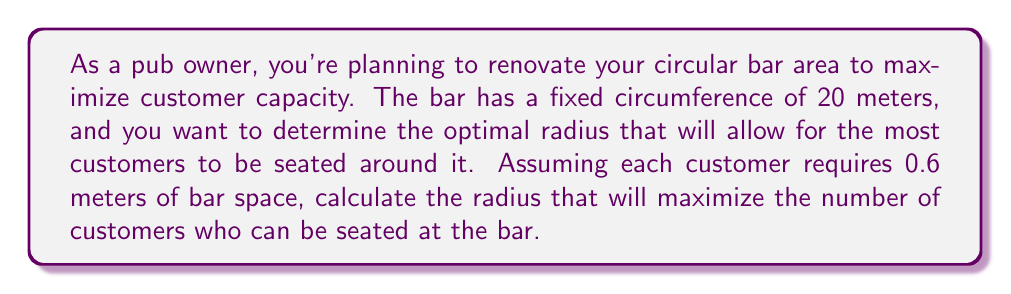Can you answer this question? Let's approach this step-by-step:

1) First, we need to express the number of customers in terms of the bar's radius. Let's call the radius $r$.

2) The circumference of the bar is fixed at 20 meters. We know that the circumference of a circle is given by $2\pi r$. So we have:

   $$2\pi r = 20$$

3) Each customer requires 0.6 meters of bar space. The number of customers $N$ that can be seated is the total circumference divided by the space each customer needs:

   $$N = \frac{20}{0.6} = \frac{100}{3}$$

4) Now, we need to express the area of the bar in terms of $r$. The area of a circle is $\pi r^2$. 

5) Our goal is to maximize this area while maintaining the fixed circumference. We can express $r$ in terms of the circumference:

   $$r = \frac{20}{2\pi} = \frac{10}{\pi}$$

6) Substituting this into the area formula:

   $$A = \pi (\frac{10}{\pi})^2 = \frac{100}{\pi}$$

7) This is the maximum area possible given the constraints.

8) To find the optimal radius, we simply use the formula we derived in step 5:

   $$r = \frac{10}{\pi} \approx 3.183$$

9) We can verify that this indeed allows for $\frac{100}{3} \approx 33.33$ customers, which rounds down to 33 customers.

[asy]
unitsize(30);
draw(circle((0,0),3.183), rgb(0,0,1));
dot((0,0), rgb(1,0,0));
draw((0,0)--(3.183,0), arrow=Arrow(TeXHead), rgb(1,0,0));
label("r", (1.5,0.3), rgb(1,0,0));
[/asy]
Answer: The optimal radius for the circular bar is $\frac{10}{\pi} \approx 3.183$ meters, which will allow for 33 customers to be seated. 